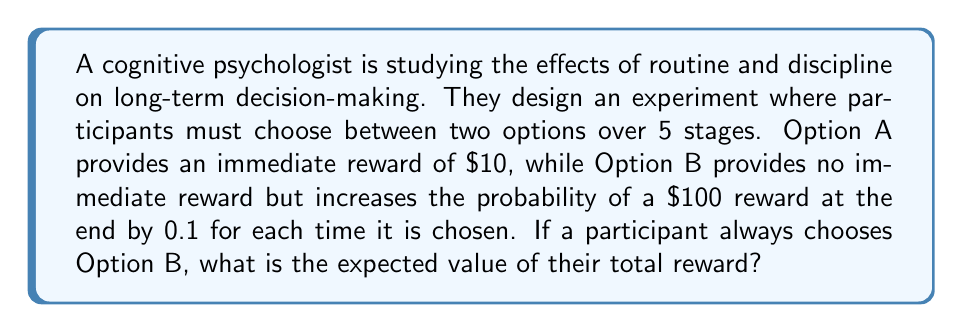Can you solve this math problem? Let's approach this step-by-step:

1) First, we need to calculate the probability of receiving the $100 reward at the end if the participant always chooses Option B.

   - Each time Option B is chosen, the probability increases by 0.1
   - There are 5 stages, so the final probability is: $5 \times 0.1 = 0.5$ or 50%

2) Now, we can calculate the expected value of the final reward:

   $$E(\text{final reward}) = 0.5 \times \$100 + 0.5 \times \$0 = \$50$$

3) The participant receives no immediate rewards when always choosing Option B, so the total expected value is just the expected value of the final reward.

4) Therefore, the expected value of the total reward is $50.

This problem illustrates the concept of delayed gratification, which is central to the study of discipline and routine in cognitive psychology. By consistently choosing the option with no immediate reward (Option B), the participant maximizes their expected long-term gain.
Answer: $50 